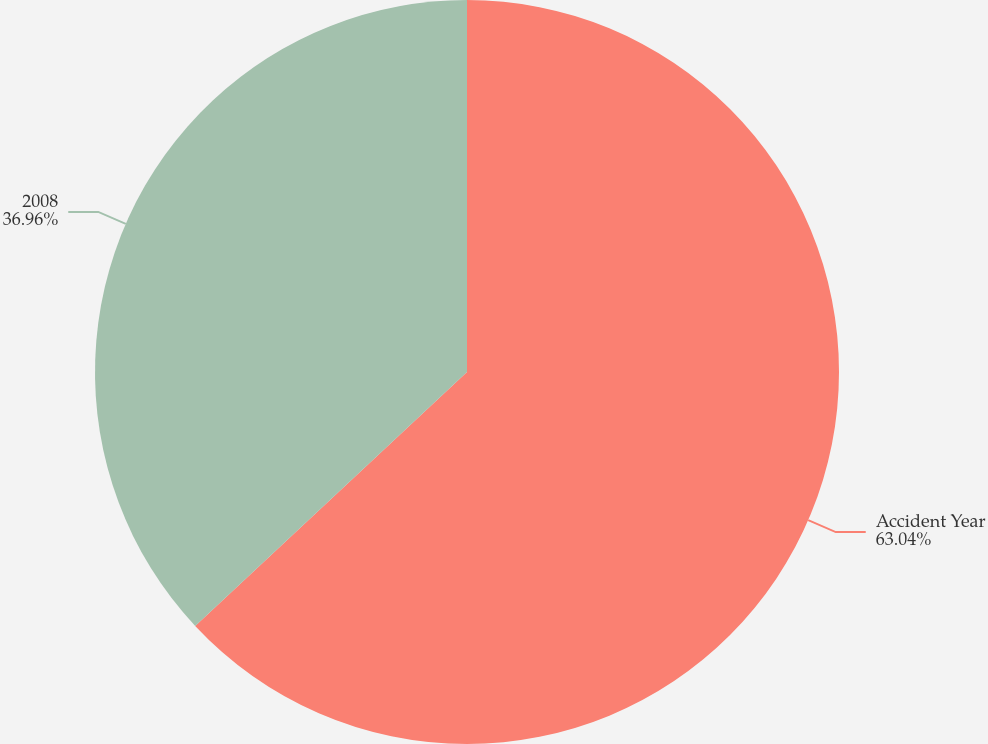Convert chart. <chart><loc_0><loc_0><loc_500><loc_500><pie_chart><fcel>Accident Year<fcel>2008<nl><fcel>63.04%<fcel>36.96%<nl></chart> 